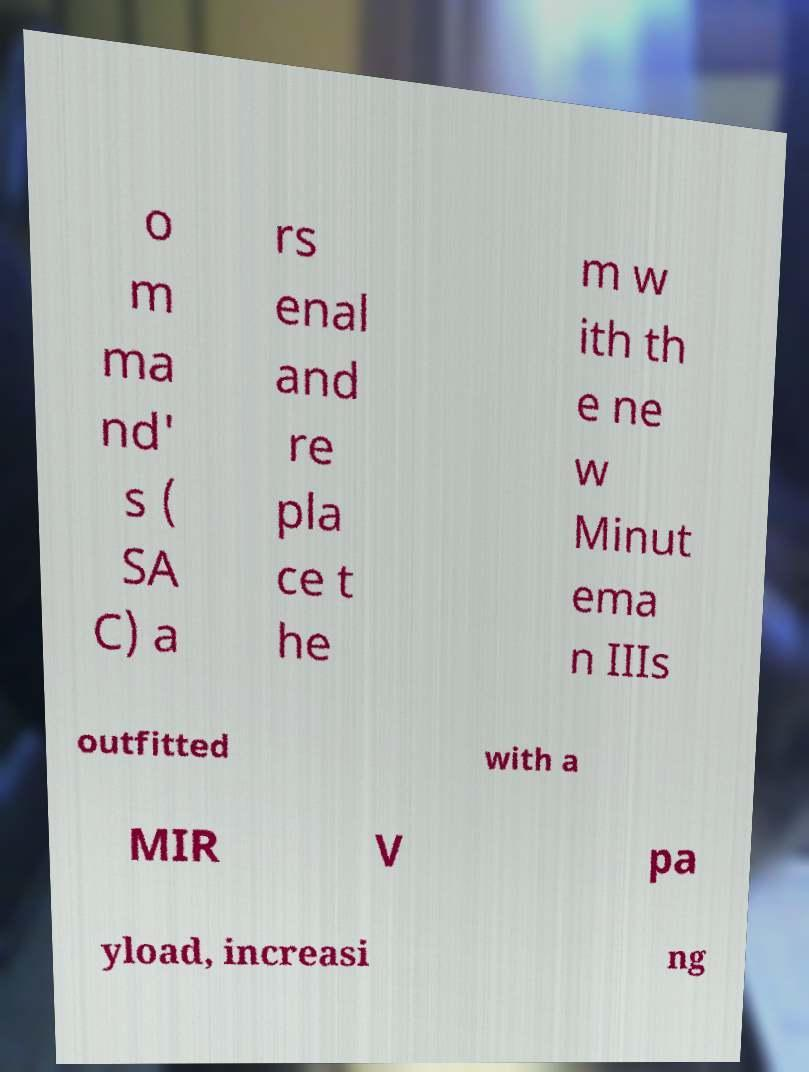For documentation purposes, I need the text within this image transcribed. Could you provide that? o m ma nd' s ( SA C) a rs enal and re pla ce t he m w ith th e ne w Minut ema n IIIs outfitted with a MIR V pa yload, increasi ng 